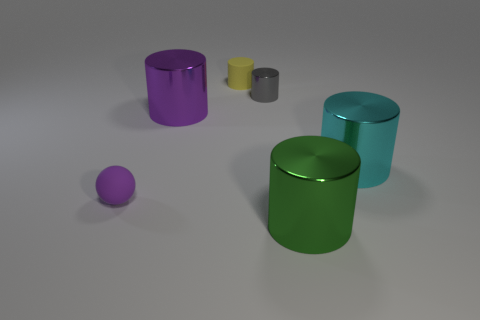The purple thing that is the same shape as the large cyan metal thing is what size? large 